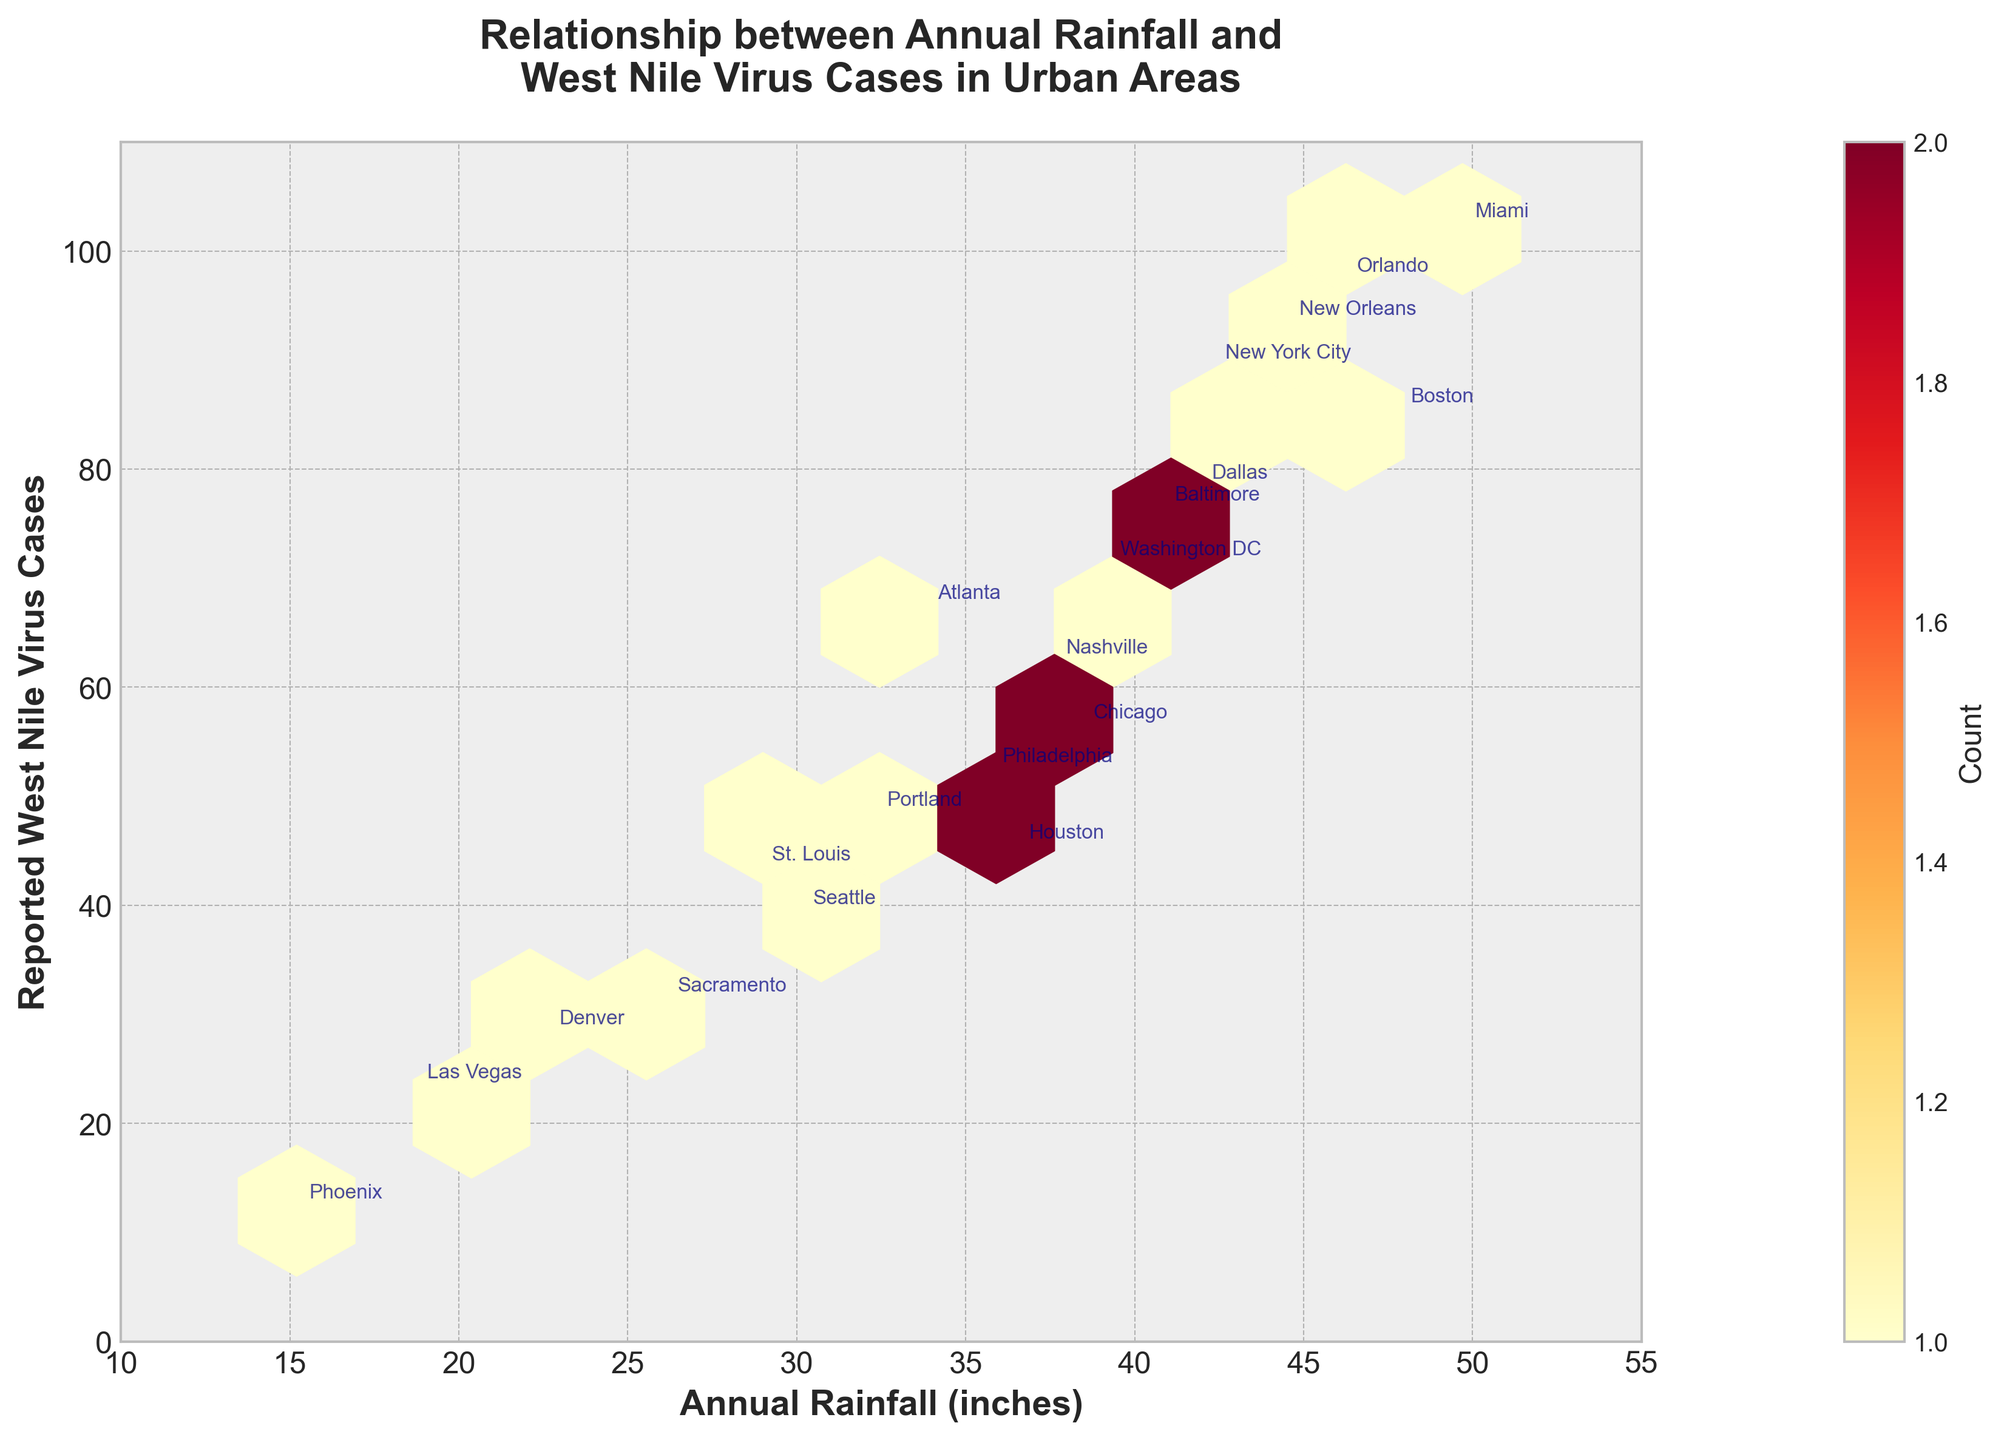What is the title of the plot? The title is located at the top, centered, and can be read directly from the figure.
Answer: Relationship between Annual Rainfall and West Nile Virus Cases in Urban Areas What color scheme is used for the hexes in the plot? The color scheme is noticeable from the hexes, ranging from lighter to darker shades.
Answer: Yellow, Orange, Red How does the annual rainfall relate to the number of West Nile Virus cases according to the plot? Visual observation shows a general trend; higher rainfall is associated with more reported cases.
Answer: Positive correlation Which city has the highest number of reported West Nile Virus cases? Look for the data point with the highest y-value and find the annotated city name.
Answer: Miami What is the approximate range of annual rainfall in the cities plotted? By observing the x-axis limits and the spread of data points along the axis.
Answer: 10 to 55 inches What can be inferred from the hexbin plot about cities with annual rainfall between 40-50 inches in terms of West Nile Virus cases? Examine the density and color of hexes in this rainfall range and observe the associated y-values.
Answer: Generally have higher WNV cases How many cities reported fewer than 30 cases of West Nile Virus? Check the annotations of the data points with y-values below 30.
Answer: Three (Phoenix, Las Vegas, Denver) Are there cities with similar rainfall but significantly different numbers of West Nile Virus cases? Compare cities with close x-values but different y-values, observing the annotations.
Answer: Yes, examples include Sacramento and Denver Is there a concentration of cities with both low rainfall and low West Nile Virus cases? Examine the hexagons in the lower left part of the plot to see the color intensity and number of hexes.
Answer: Yes, in the lower left section What can be deduced about cities with annual rainfall above 45 inches? Observe the number of cases correlated with rainfall above 45 inches and their density.
Answer: Tend to have the highest WNV cases 